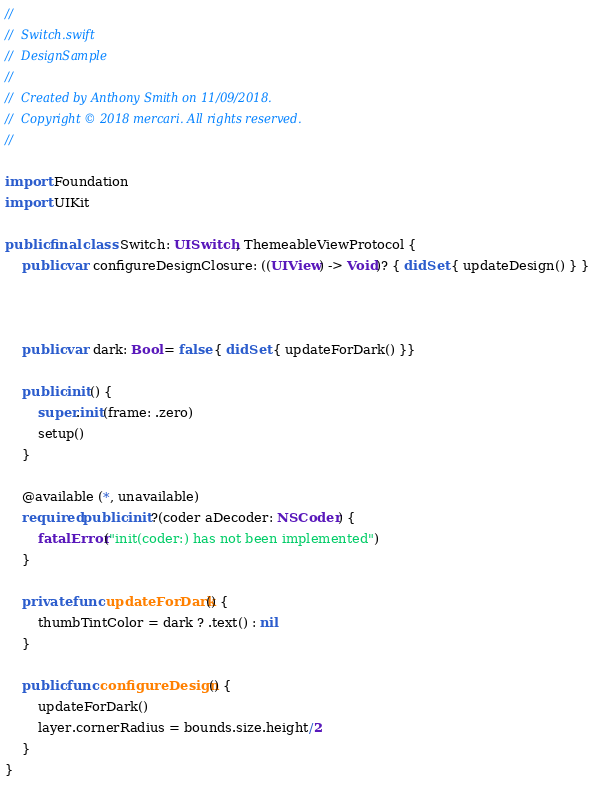<code> <loc_0><loc_0><loc_500><loc_500><_Swift_>//
//  Switch.swift
//  DesignSample
//
//  Created by Anthony Smith on 11/09/2018.
//  Copyright © 2018 mercari. All rights reserved.
//

import Foundation
import UIKit

public final class Switch: UISwitch, ThemeableViewProtocol {
    public var configureDesignClosure: ((UIView) -> Void)? { didSet { updateDesign() } }



    public var dark: Bool = false { didSet { updateForDark() }}

    public init() {
        super.init(frame: .zero)
        setup()
    }

    @available (*, unavailable)
    required public init?(coder aDecoder: NSCoder) {
        fatalError("init(coder:) has not been implemented")
    }

    private func updateForDark() {
        thumbTintColor = dark ? .text() : nil
    }

    public func configureDesign() {
        updateForDark()
        layer.cornerRadius = bounds.size.height/2
    }
}
</code> 